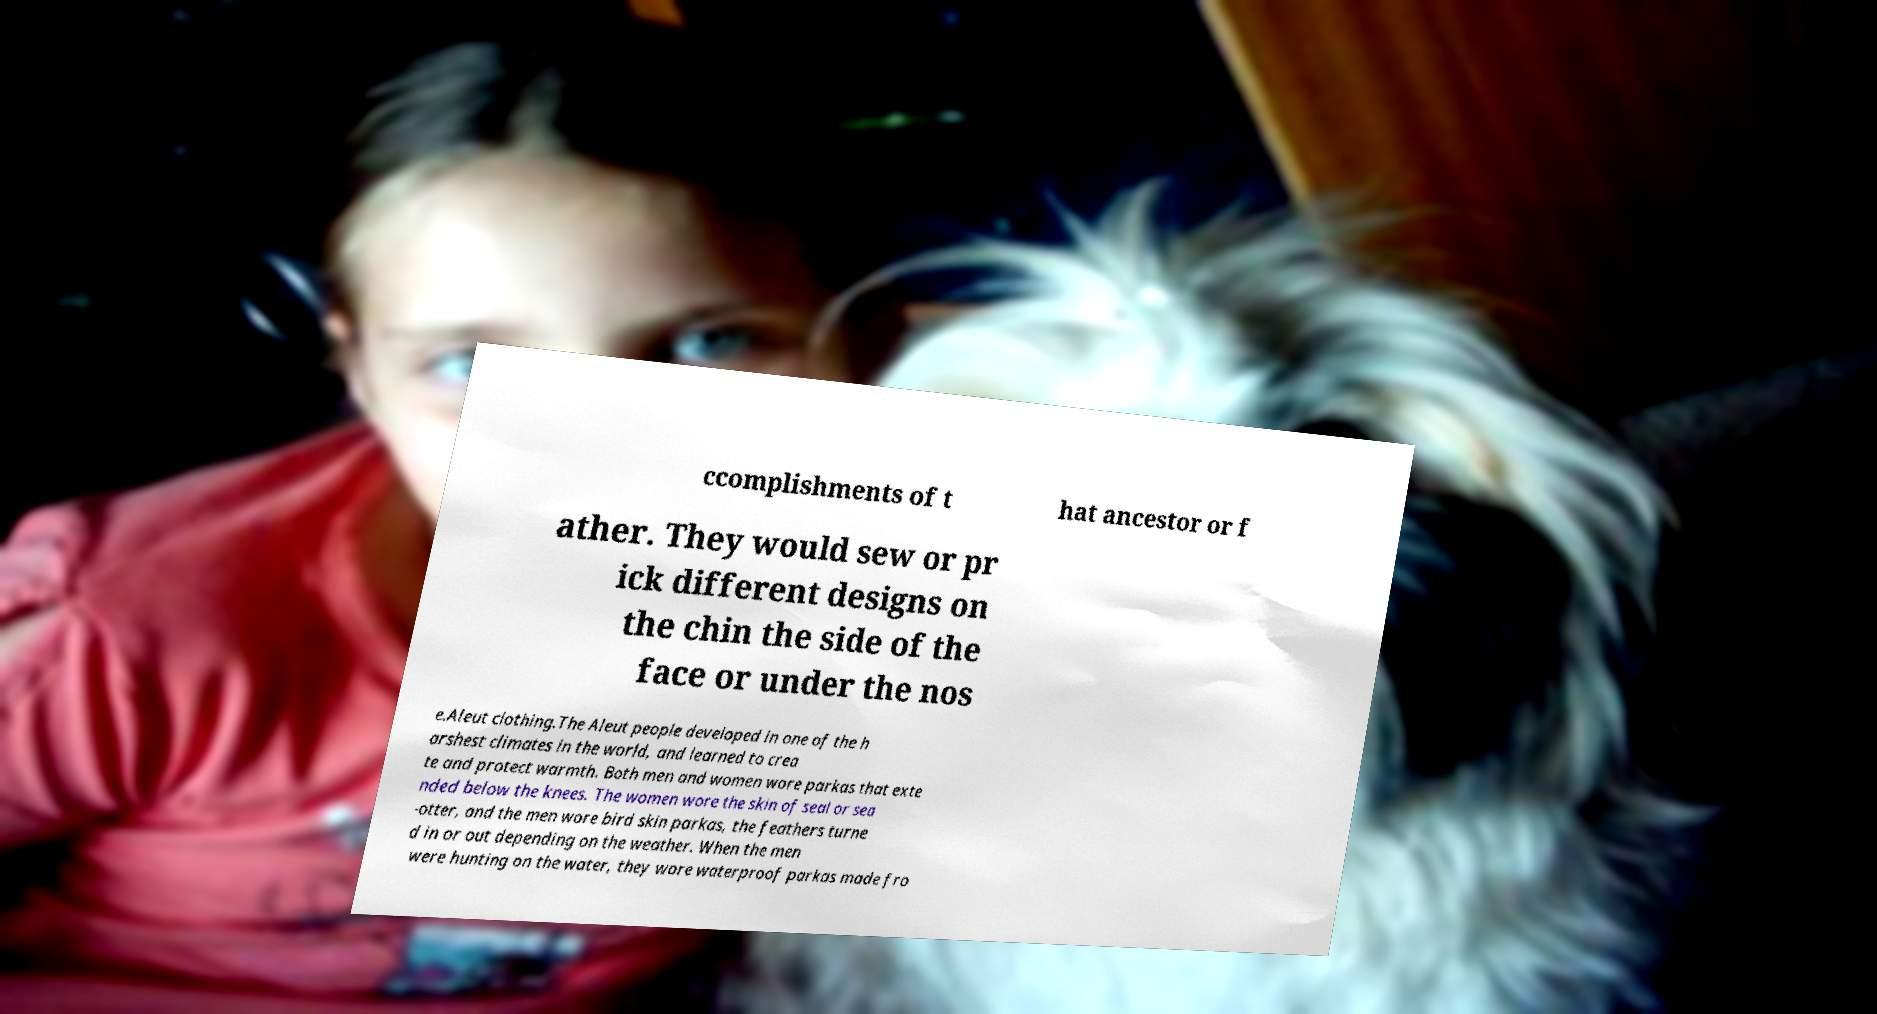There's text embedded in this image that I need extracted. Can you transcribe it verbatim? ccomplishments of t hat ancestor or f ather. They would sew or pr ick different designs on the chin the side of the face or under the nos e.Aleut clothing.The Aleut people developed in one of the h arshest climates in the world, and learned to crea te and protect warmth. Both men and women wore parkas that exte nded below the knees. The women wore the skin of seal or sea -otter, and the men wore bird skin parkas, the feathers turne d in or out depending on the weather. When the men were hunting on the water, they wore waterproof parkas made fro 